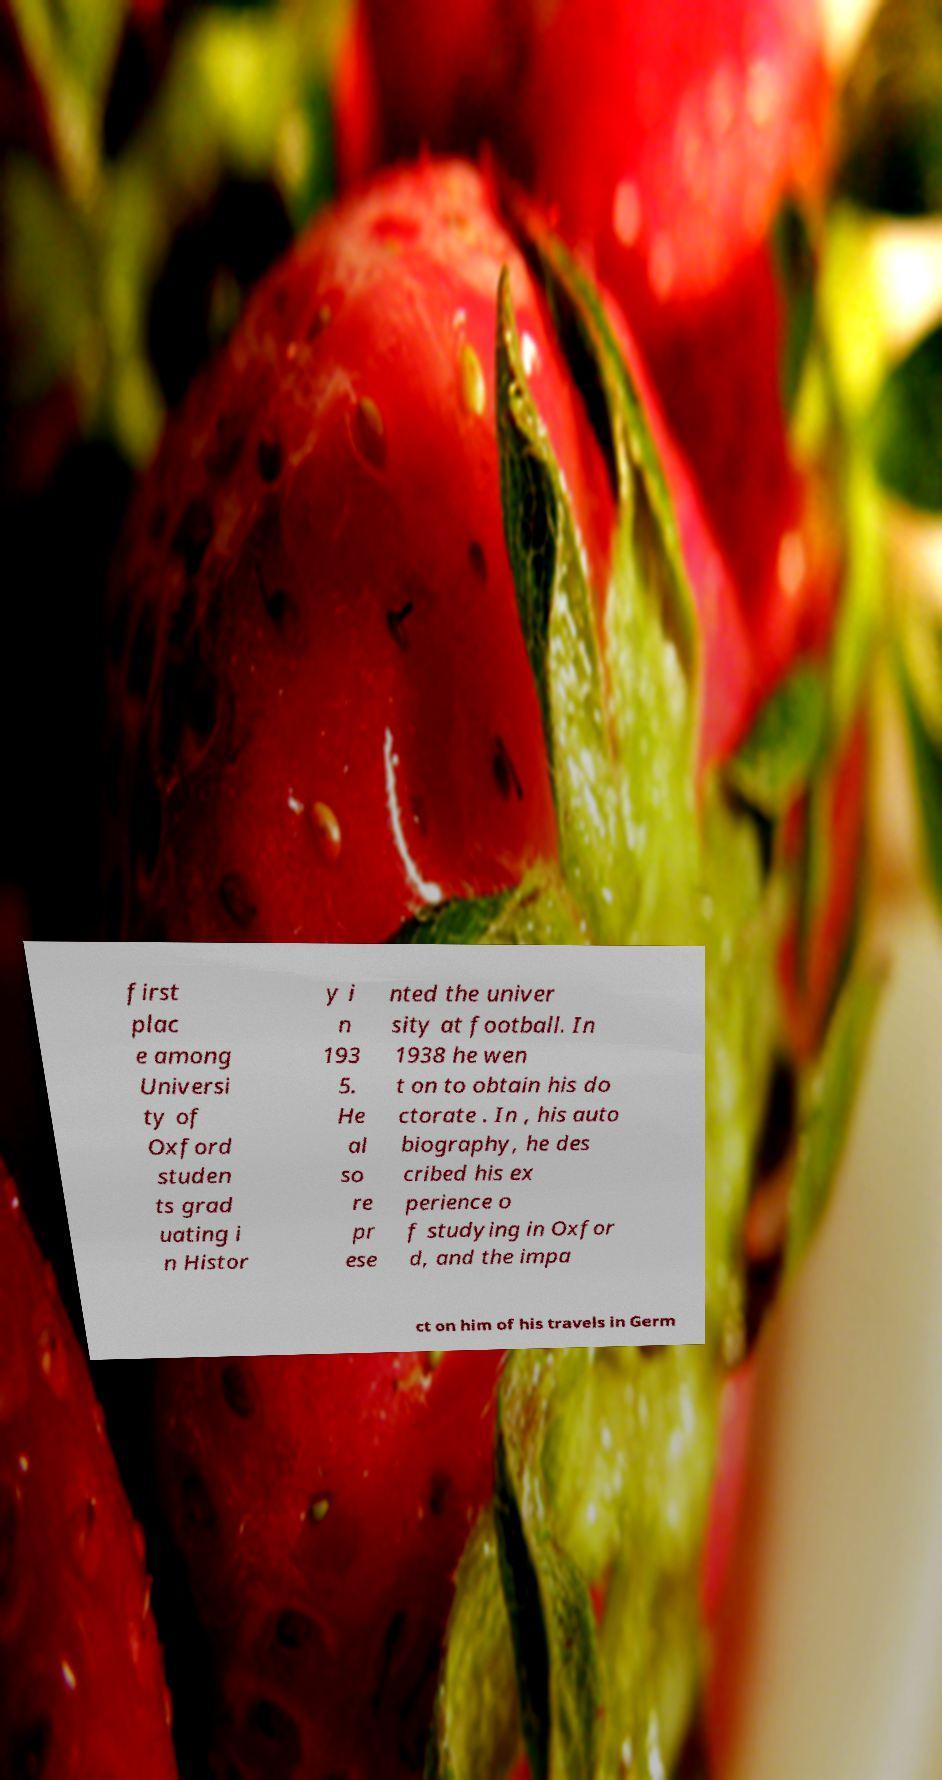Could you extract and type out the text from this image? first plac e among Universi ty of Oxford studen ts grad uating i n Histor y i n 193 5. He al so re pr ese nted the univer sity at football. In 1938 he wen t on to obtain his do ctorate . In , his auto biography, he des cribed his ex perience o f studying in Oxfor d, and the impa ct on him of his travels in Germ 